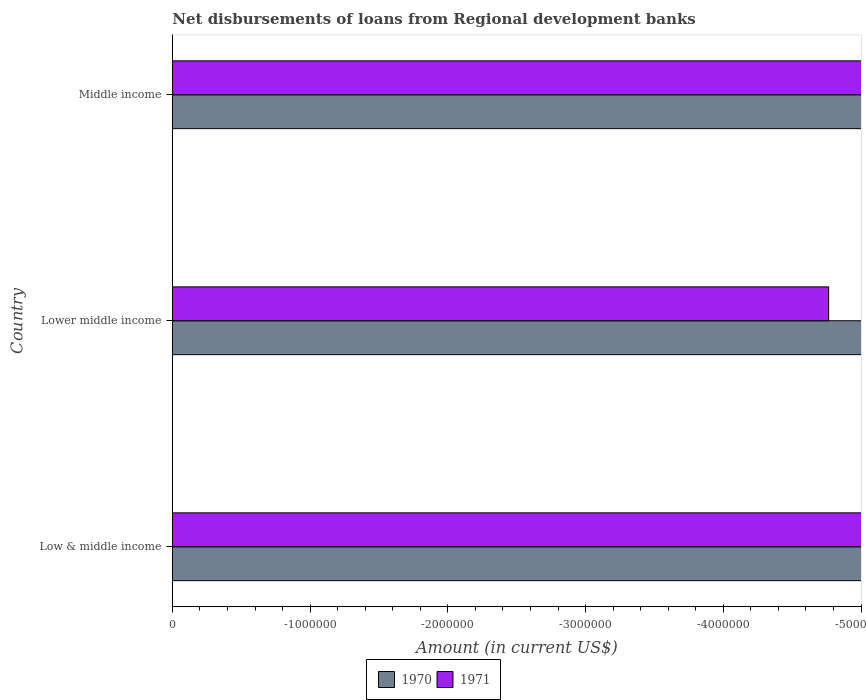Are the number of bars on each tick of the Y-axis equal?
Provide a short and direct response. Yes. How many bars are there on the 1st tick from the top?
Provide a short and direct response. 0. How many bars are there on the 1st tick from the bottom?
Give a very brief answer. 0. In how many cases, is the number of bars for a given country not equal to the number of legend labels?
Provide a succinct answer. 3. Across all countries, what is the minimum amount of disbursements of loans from regional development banks in 1970?
Make the answer very short. 0. What is the average amount of disbursements of loans from regional development banks in 1970 per country?
Offer a terse response. 0. In how many countries, is the amount of disbursements of loans from regional development banks in 1971 greater than the average amount of disbursements of loans from regional development banks in 1971 taken over all countries?
Your answer should be very brief. 0. How many countries are there in the graph?
Provide a succinct answer. 3. Are the values on the major ticks of X-axis written in scientific E-notation?
Keep it short and to the point. No. Where does the legend appear in the graph?
Give a very brief answer. Bottom center. How are the legend labels stacked?
Make the answer very short. Horizontal. What is the title of the graph?
Make the answer very short. Net disbursements of loans from Regional development banks. Does "2010" appear as one of the legend labels in the graph?
Ensure brevity in your answer.  No. What is the label or title of the X-axis?
Your answer should be very brief. Amount (in current US$). What is the Amount (in current US$) of 1970 in Low & middle income?
Ensure brevity in your answer.  0. What is the Amount (in current US$) of 1970 in Lower middle income?
Make the answer very short. 0. What is the Amount (in current US$) of 1971 in Lower middle income?
Keep it short and to the point. 0. What is the Amount (in current US$) of 1971 in Middle income?
Offer a terse response. 0. What is the total Amount (in current US$) in 1971 in the graph?
Keep it short and to the point. 0. What is the average Amount (in current US$) of 1970 per country?
Offer a very short reply. 0. 